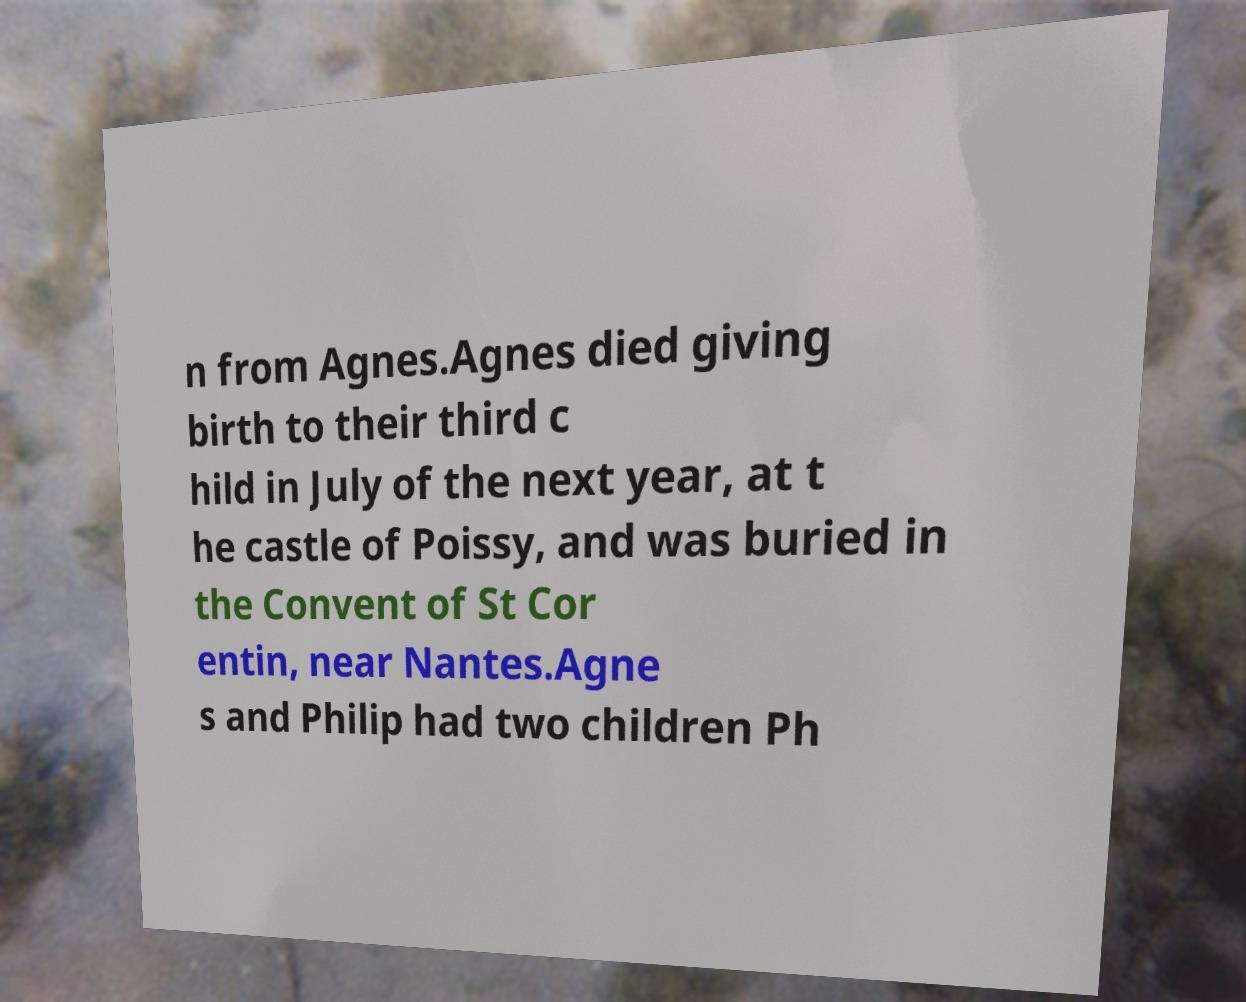Could you extract and type out the text from this image? n from Agnes.Agnes died giving birth to their third c hild in July of the next year, at t he castle of Poissy, and was buried in the Convent of St Cor entin, near Nantes.Agne s and Philip had two children Ph 